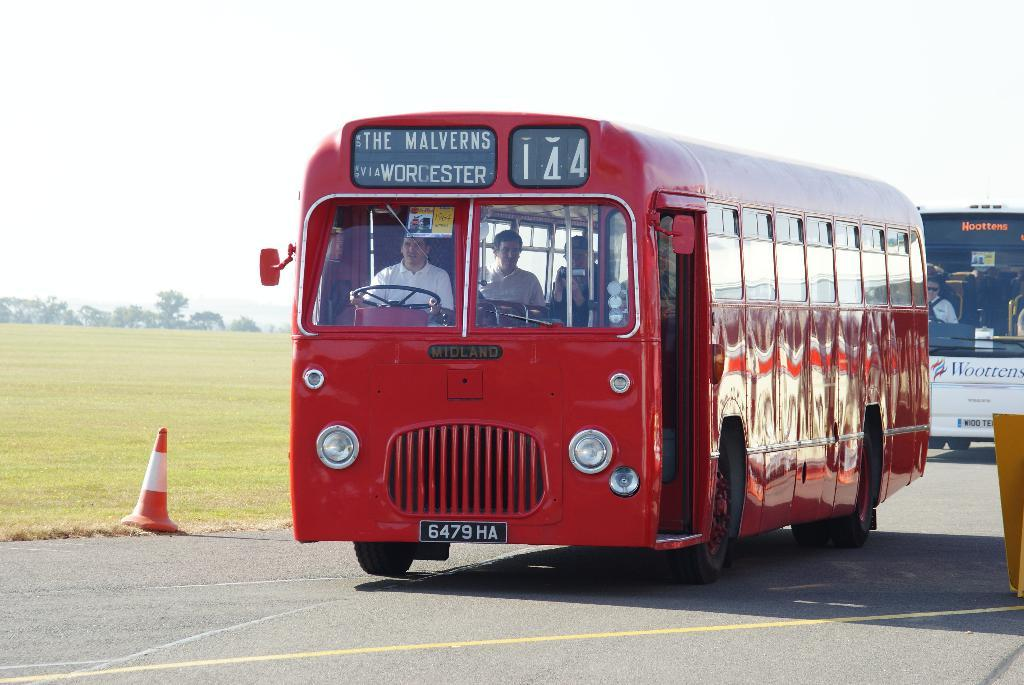<image>
Give a short and clear explanation of the subsequent image. Old red bus going to The Malverns and Worchester. 